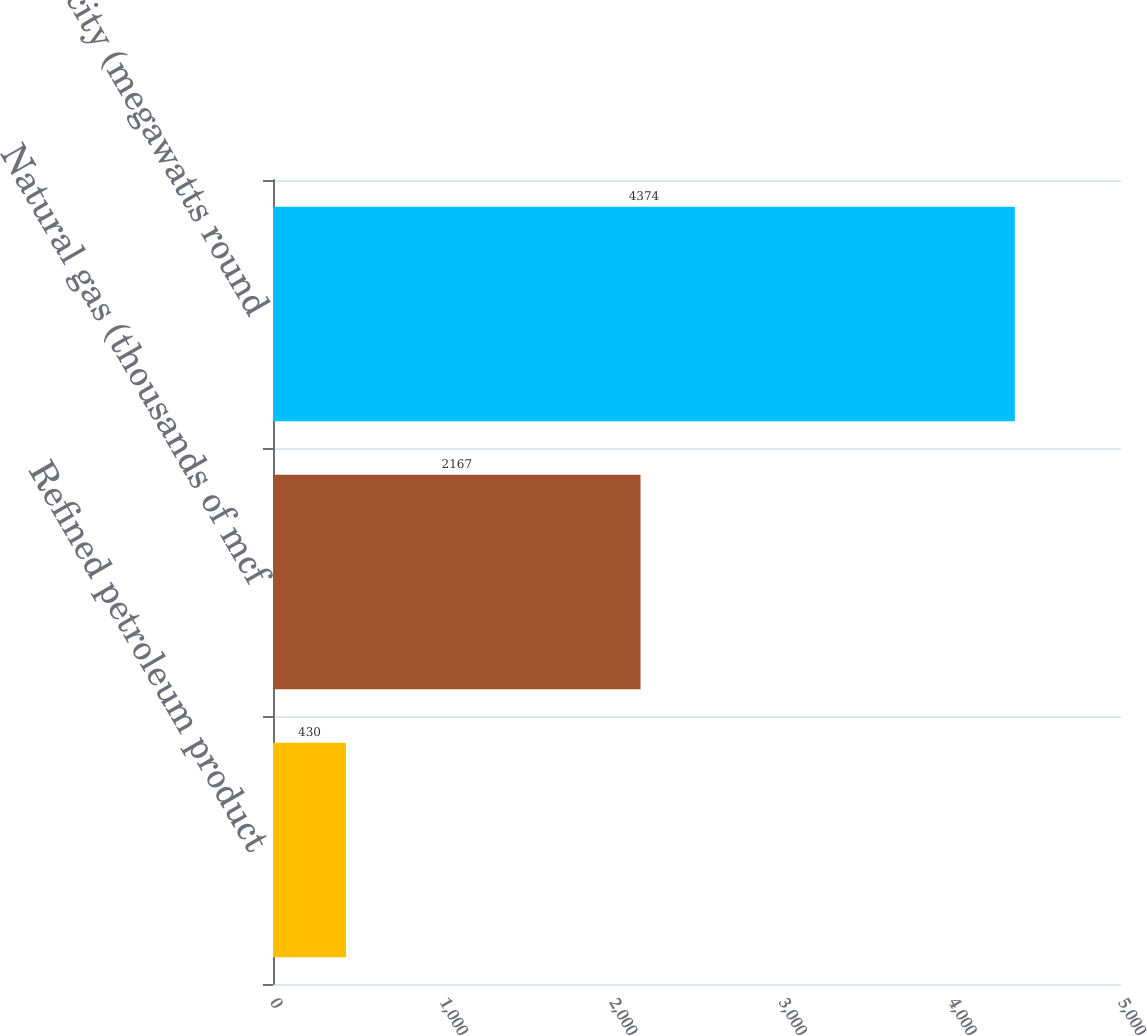Convert chart to OTSL. <chart><loc_0><loc_0><loc_500><loc_500><bar_chart><fcel>Refined petroleum product<fcel>Natural gas (thousands of mcf<fcel>Electricity (megawatts round<nl><fcel>430<fcel>2167<fcel>4374<nl></chart> 